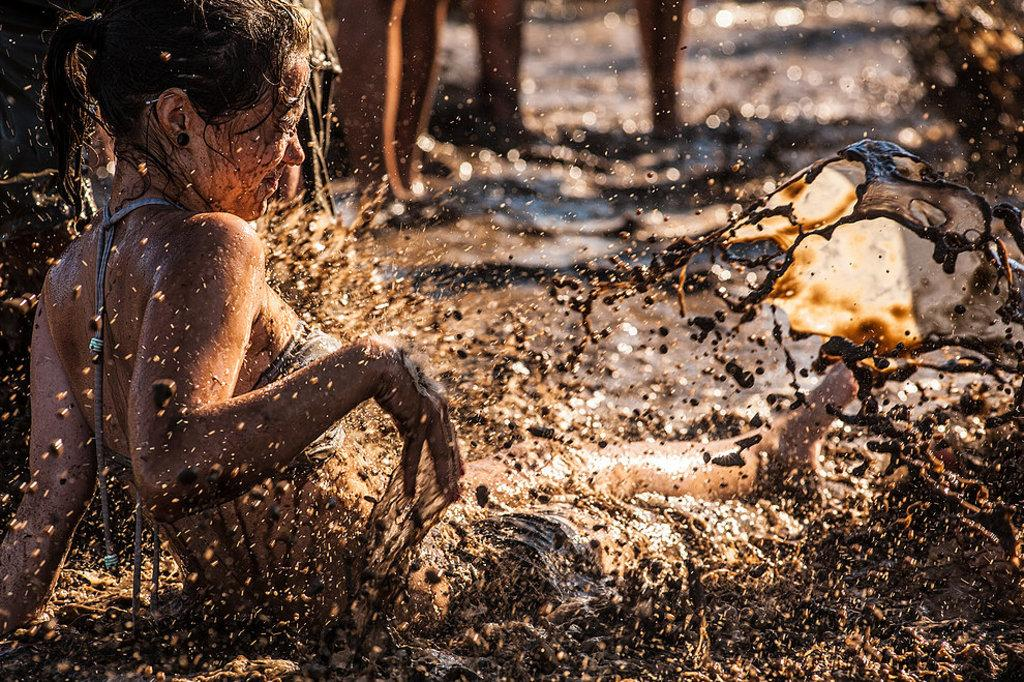Who is the main subject in the image? There is a woman in the center of the image. What is the woman doing in the image? The woman is playing in muddy water. Are there any other people visible in the image? Yes, there are persons standing in the background of the image. Can you see a hen in the image? There is no hen present in the image. Is there a boat in the image? There is no boat present in the image. 